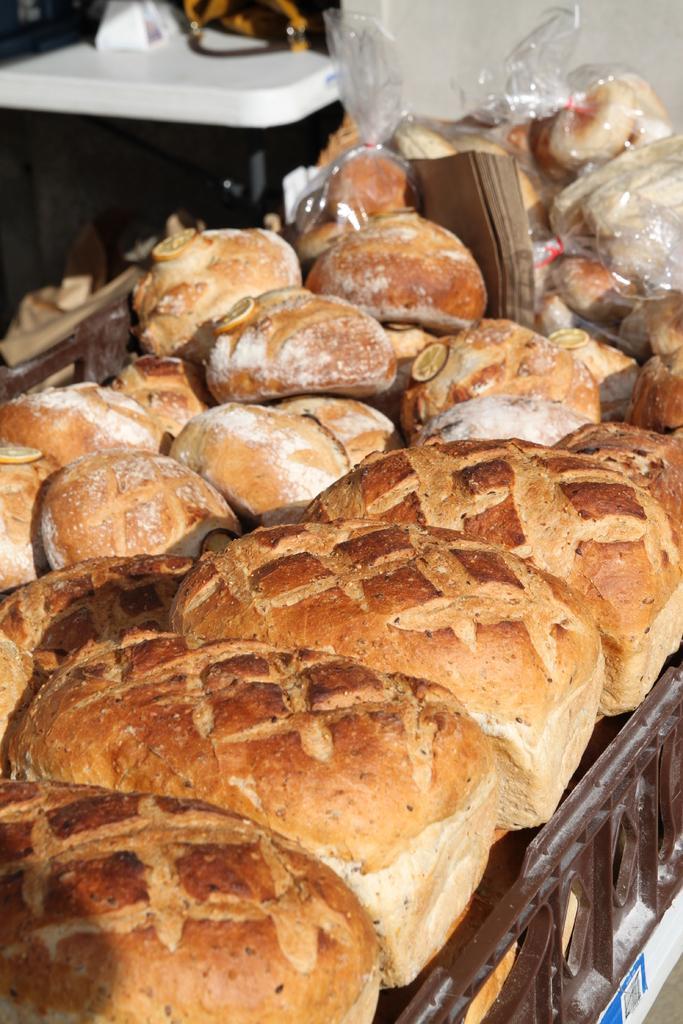Describe this image in one or two sentences. Here we can see breads, plastic covers and things. 